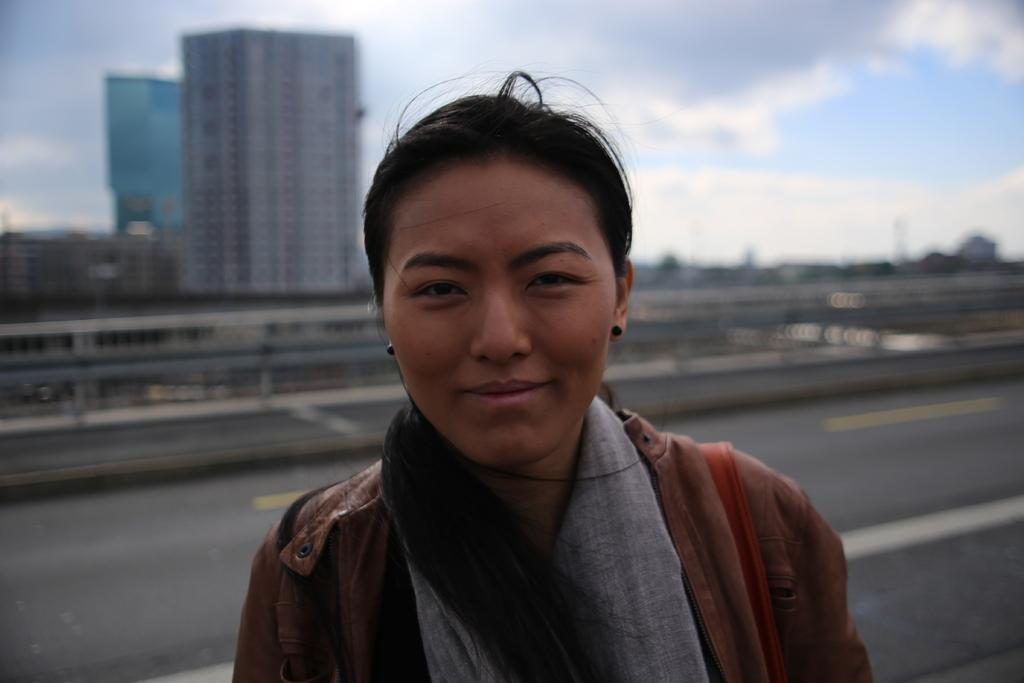Who is the main subject in the foreground of the image? There is a woman in the foreground of the image. What is the primary feature in the middle of the image? There is a road in the image. What can be seen in the background of the image? There are buildings, trees, and the sky visible in the background of the image. What is the condition of the sky in the image? The sky is visible in the background of the image, and there are clouds present. How does the woman in the image say good-bye to the buildings in the background? There is no indication in the image that the woman is saying good-bye to the buildings or engaging in any form of communication with them. --- Facts: 1. There is a car in the image. 2. The car is red. 3. The car has four wheels. 4. There is a person in the car. 5. The person is wearing a hat. Absurd Topics: parrot, piano, penguin Conversation: What is the main subject in the image? There is a car in the image. What color is the car? The car is red. How many wheels does the car have? The car has four wheels. Is there anyone inside the car? Yes, there is a person in the car. What is the person wearing in the car? The person is wearing a hat. Reasoning: Let's think step by step in order to produce the conversation. We start by identifying the main subject of the image, which is the car. Next, we describe specific features of the car, such as the color and the number of wheels. Then, we observe the actions of the person inside the car, noting that they are wearing a hat. Finally, we ensure that the language is simple and clear. Absurd Question/Answer: Can you hear the parrot playing the piano in the image? There is no parrot or piano present in the image. 